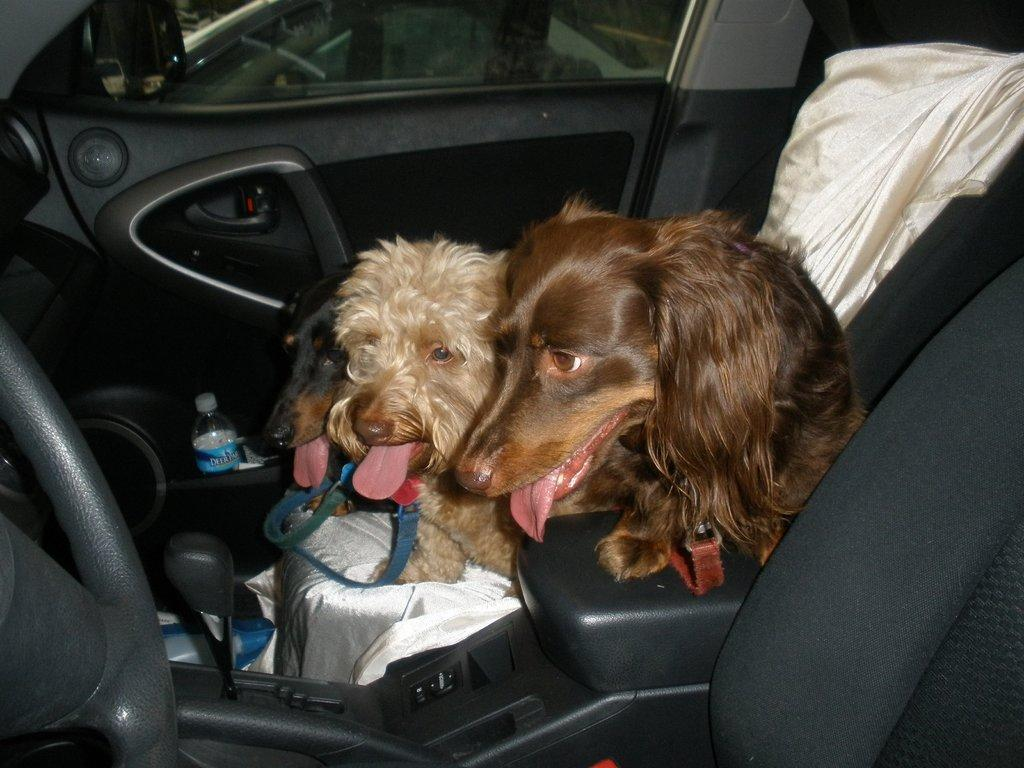What animals are present inside the vehicle in the image? There are two dogs inside the vehicle in the image. What type of object can be seen in the image? There is a cloth in the image. What is another object visible in the image? There is a bottle in the image. What feature of the vehicle can be seen in the image? There is a door in the image. Where is the sink located in the image? There is no sink present in the image. How does the stop sign affect the movement of the vehicle in the image? There is no stop sign mentioned in the image, so its effect on the vehicle's movement cannot be determined. 